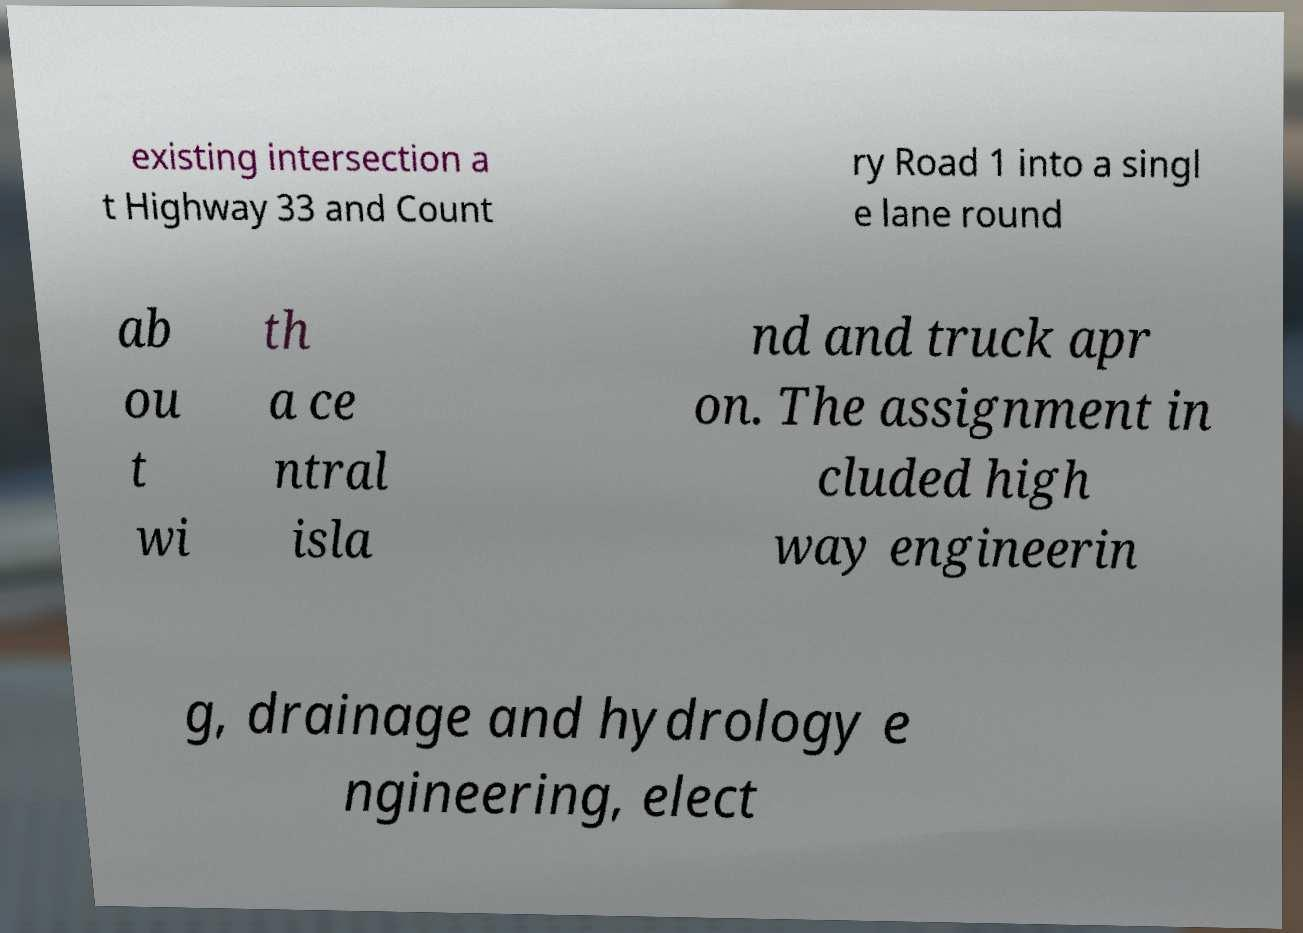Can you accurately transcribe the text from the provided image for me? existing intersection a t Highway 33 and Count ry Road 1 into a singl e lane round ab ou t wi th a ce ntral isla nd and truck apr on. The assignment in cluded high way engineerin g, drainage and hydrology e ngineering, elect 